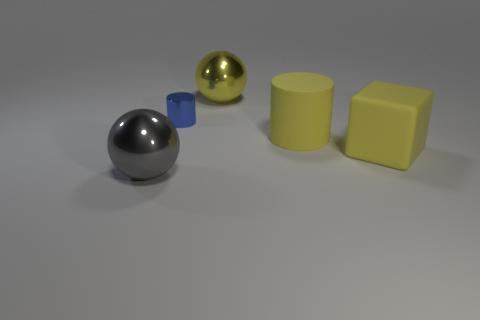Add 2 gray matte balls. How many objects exist? 7 Subtract all cubes. How many objects are left? 4 Add 5 large cylinders. How many large cylinders exist? 6 Subtract 0 cyan cylinders. How many objects are left? 5 Subtract all yellow spheres. Subtract all yellow matte blocks. How many objects are left? 3 Add 5 big spheres. How many big spheres are left? 7 